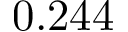Convert formula to latex. <formula><loc_0><loc_0><loc_500><loc_500>0 . 2 4 4</formula> 